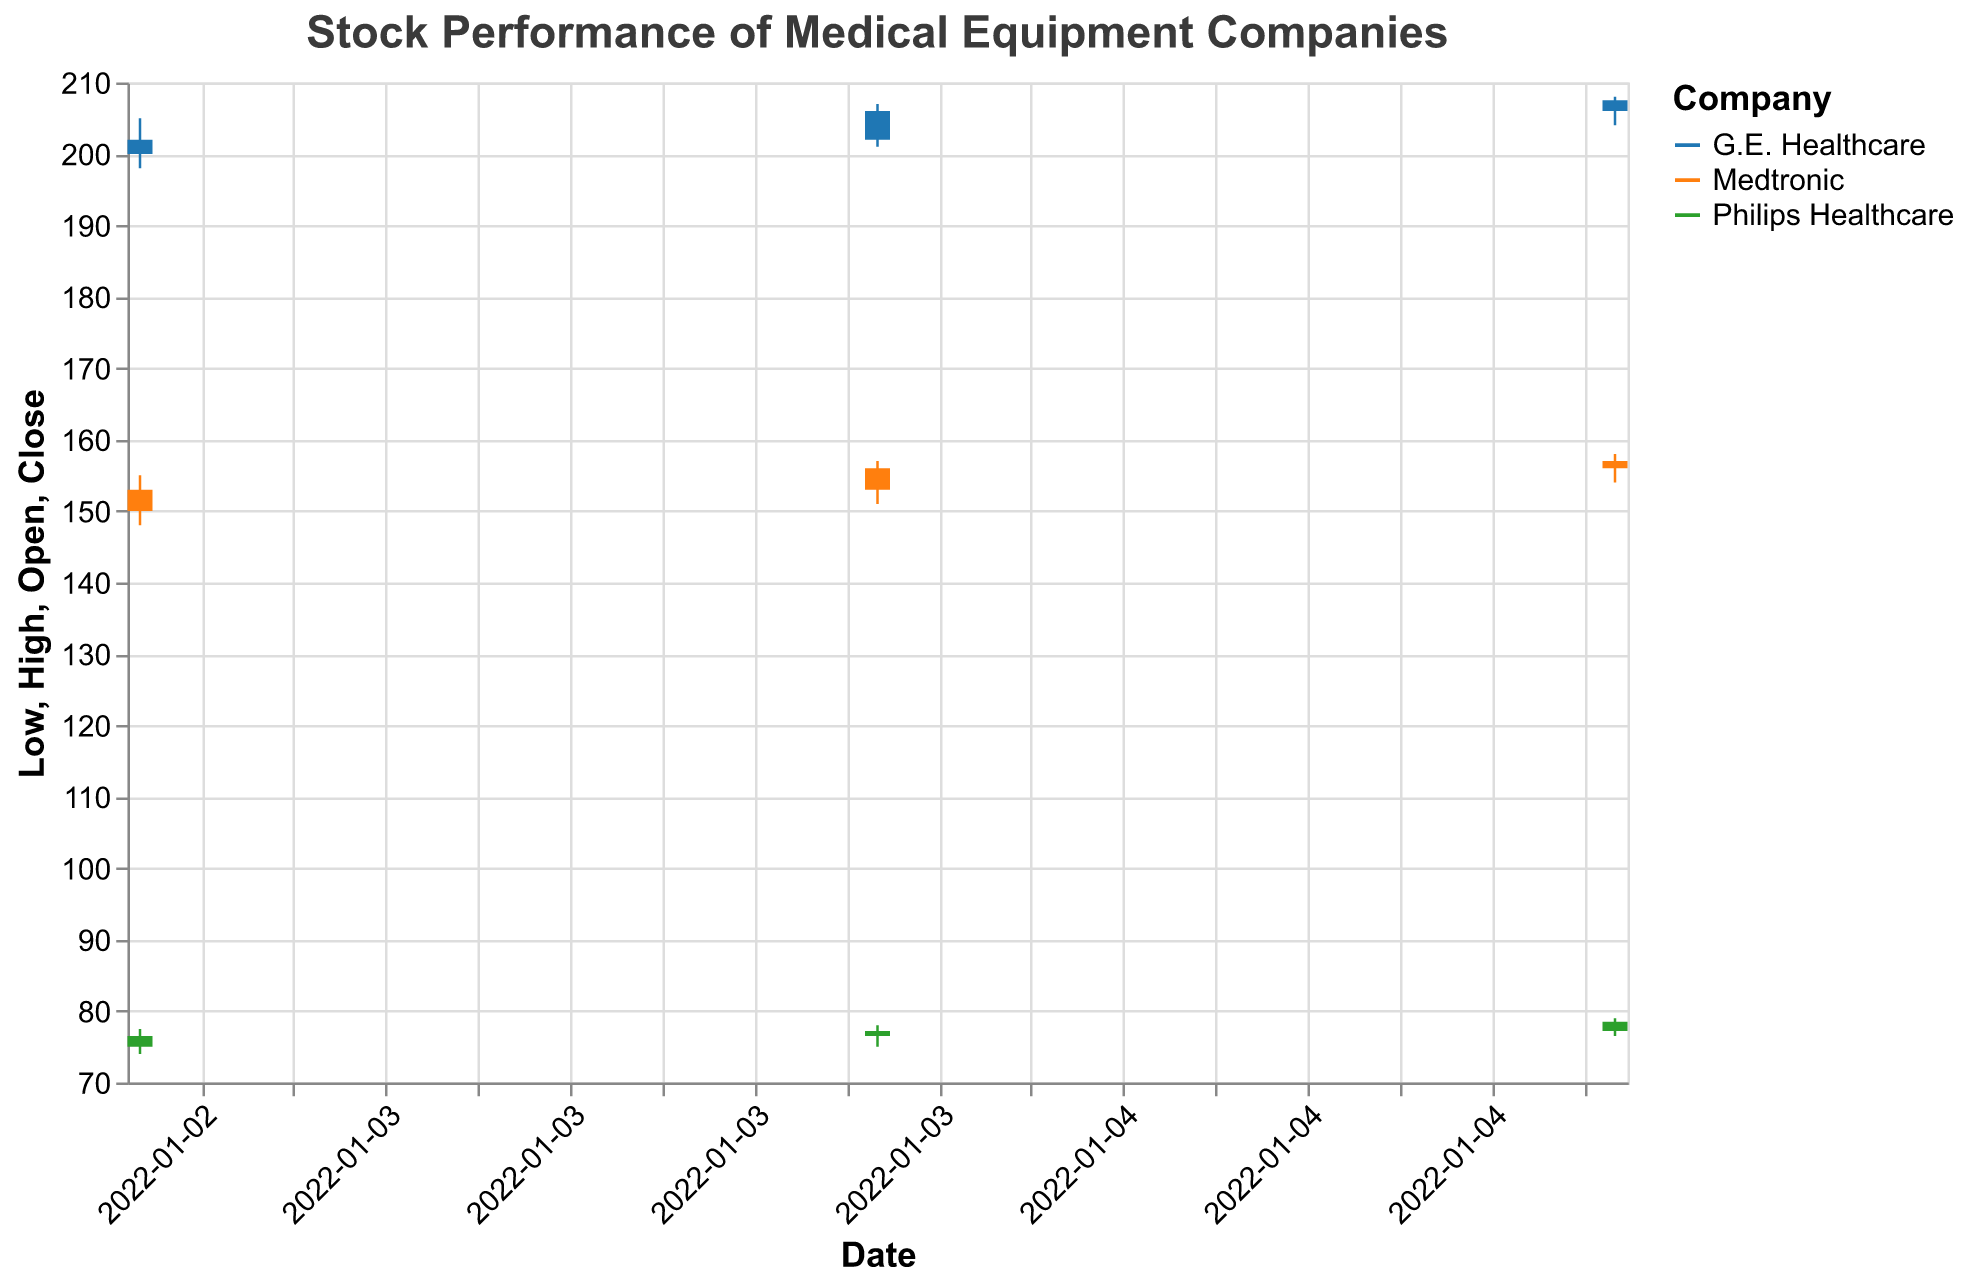What companies are shown in the candlestick plot? The candlestick plot visualizes the stock performance of three companies: Medtronic, Philips Healthcare, and G.E. Healthcare. These companies are identified by different colors in the plot.
Answer: Medtronic, Philips Healthcare, G.E. Healthcare What is the highest stock price recorded for Medtronic on January 5th, 2022? The candlestick plot shows the daily High price. For Medtronic on January 5th, 2022, the High price is indicated.
Answer: 158.00 Which company had the highest Closing price on January 5th, 2022? To find the company with the highest Closing price on January 5th, 2022, compare the Close prices for all companies on that date. G.E. Healthcare has the highest Closing price of 207.50.
Answer: G.E. Healthcare What is the difference in the Closing prices of Medtronic and Philips Healthcare on January 4th, 2022? To calculate the difference, subtract the Close price of Philips Healthcare (77.20) from Medtronic (156.00) on January 4th, 2022.
Answer: 78.80 How did the Closing price of Philips Healthcare change from January 3rd to January 5th, 2022? To find the change, subtract the Closing price on January 3rd (76.50) from the Closing price on January 5th (78.50).
Answer: 2.00 Which company had the highest trading volume on January 4th, 2022? The candlestick plot includes a tooltip showing Volume for each company on January 4th, 2022. Medtronic had the highest trading volume with 1,600,000.
Answer: Medtronic For G.E. Healthcare, what is the difference between the High and Low prices on January 4th, 2022? Subtract the Low price (201.00) from the High price (207.00) for G.E. Healthcare on January 4th, 2022.
Answer: 6.00 What trend can you observe in the Closing prices of Medtronic from January 3rd to January 5th, 2022? Observing the candlestick bars for Medtronic from January 3rd (153.00) to January 5th (157.00), the Closing prices show a steady increase day by day.
Answer: Increasing trend How does the Opening price on January 3rd, 2022 for G.E. Healthcare compare to its Opening price on January 5th, 2022? The Opening price for G.E. Healthcare on January 3rd was 200.00 and on January 5th it was 206.00. Compare these values to determine the difference.
Answer: 6.00 higher 